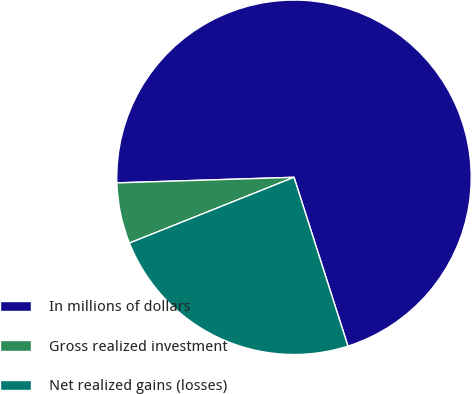Convert chart to OTSL. <chart><loc_0><loc_0><loc_500><loc_500><pie_chart><fcel>In millions of dollars<fcel>Gross realized investment<fcel>Net realized gains (losses)<nl><fcel>70.58%<fcel>5.55%<fcel>23.87%<nl></chart> 